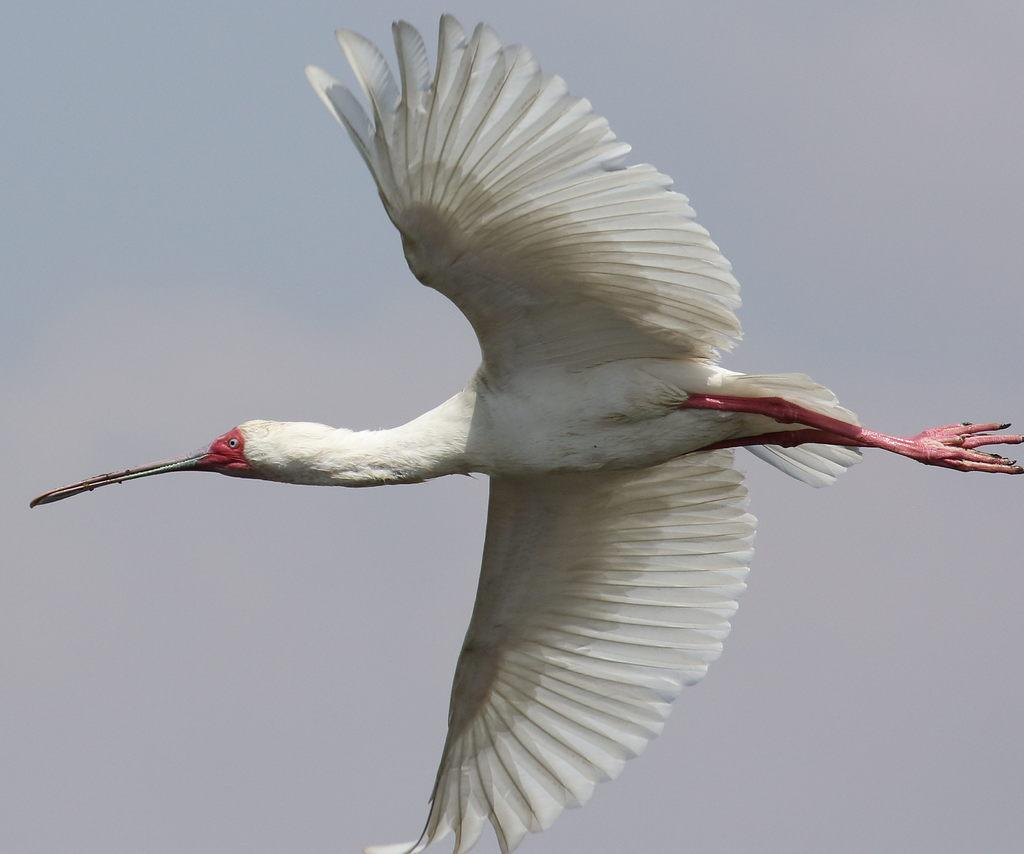What type of animal can be seen in the image? There is a white bird in the image. What is the bird doing in the image? The bird is flying in the sky. In which direction is the bird flying? The bird is flying towards the left. What is a distinctive feature of the bird's appearance? The bird has a long beak. How does the bird use the string to comb its feathers in the image? There is no string or comb present in the image; the bird is simply flying with a long beak. 